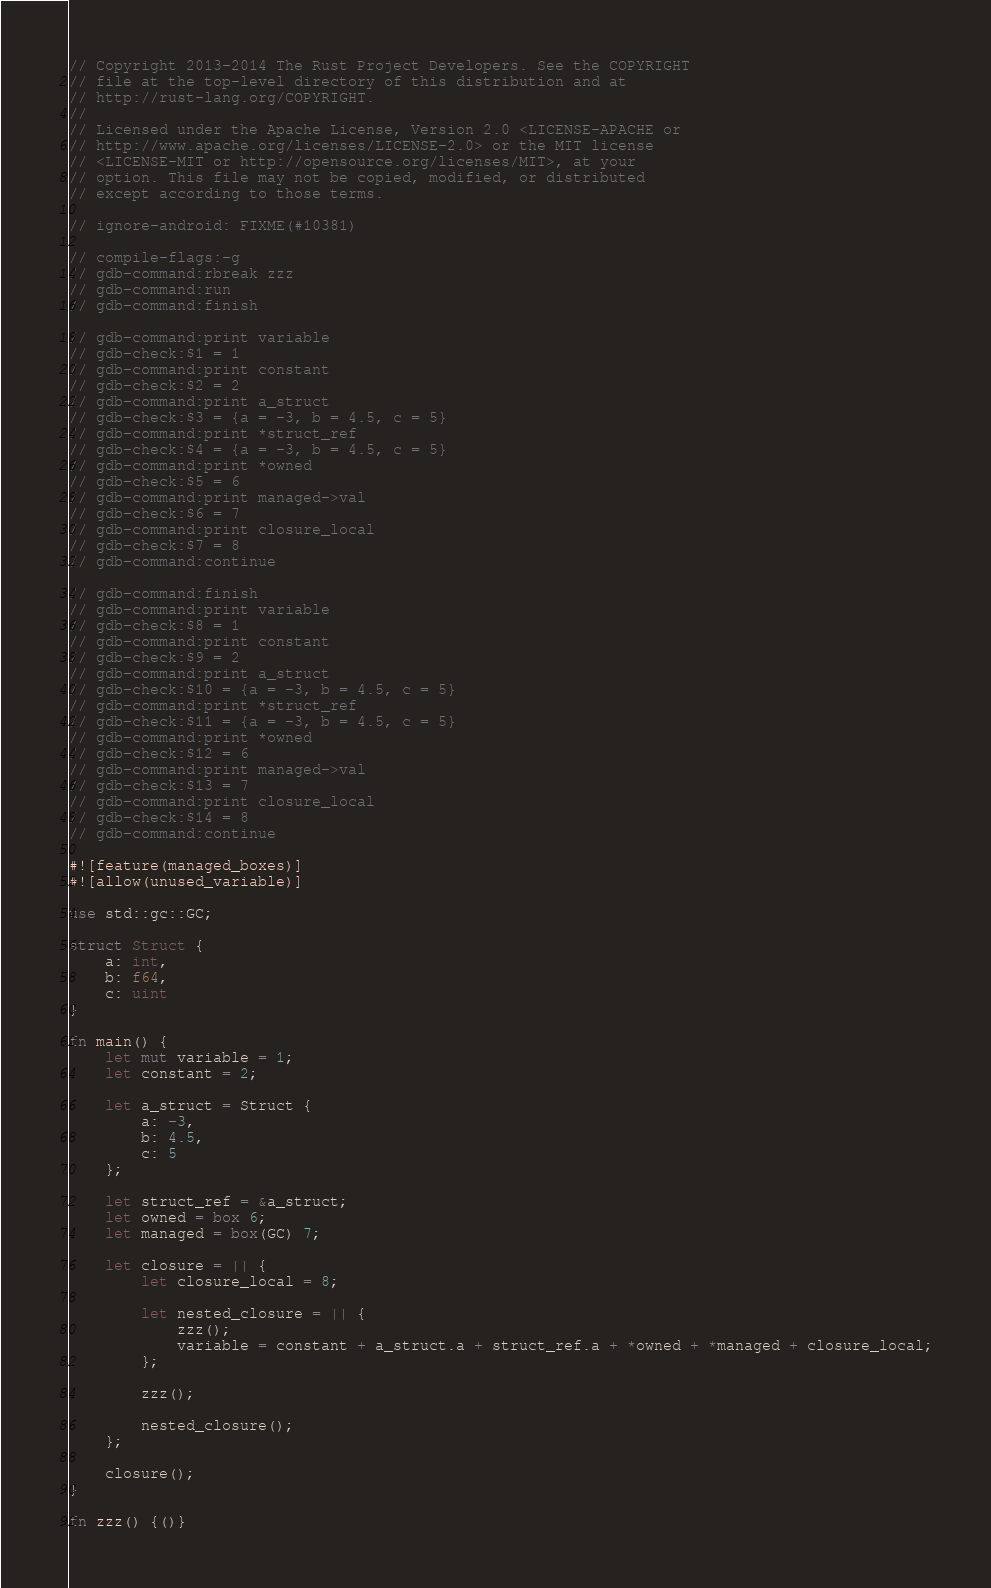Convert code to text. <code><loc_0><loc_0><loc_500><loc_500><_Rust_>// Copyright 2013-2014 The Rust Project Developers. See the COPYRIGHT
// file at the top-level directory of this distribution and at
// http://rust-lang.org/COPYRIGHT.
//
// Licensed under the Apache License, Version 2.0 <LICENSE-APACHE or
// http://www.apache.org/licenses/LICENSE-2.0> or the MIT license
// <LICENSE-MIT or http://opensource.org/licenses/MIT>, at your
// option. This file may not be copied, modified, or distributed
// except according to those terms.

// ignore-android: FIXME(#10381)

// compile-flags:-g
// gdb-command:rbreak zzz
// gdb-command:run
// gdb-command:finish

// gdb-command:print variable
// gdb-check:$1 = 1
// gdb-command:print constant
// gdb-check:$2 = 2
// gdb-command:print a_struct
// gdb-check:$3 = {a = -3, b = 4.5, c = 5}
// gdb-command:print *struct_ref
// gdb-check:$4 = {a = -3, b = 4.5, c = 5}
// gdb-command:print *owned
// gdb-check:$5 = 6
// gdb-command:print managed->val
// gdb-check:$6 = 7
// gdb-command:print closure_local
// gdb-check:$7 = 8
// gdb-command:continue

// gdb-command:finish
// gdb-command:print variable
// gdb-check:$8 = 1
// gdb-command:print constant
// gdb-check:$9 = 2
// gdb-command:print a_struct
// gdb-check:$10 = {a = -3, b = 4.5, c = 5}
// gdb-command:print *struct_ref
// gdb-check:$11 = {a = -3, b = 4.5, c = 5}
// gdb-command:print *owned
// gdb-check:$12 = 6
// gdb-command:print managed->val
// gdb-check:$13 = 7
// gdb-command:print closure_local
// gdb-check:$14 = 8
// gdb-command:continue

#![feature(managed_boxes)]
#![allow(unused_variable)]

use std::gc::GC;

struct Struct {
    a: int,
    b: f64,
    c: uint
}

fn main() {
    let mut variable = 1;
    let constant = 2;

    let a_struct = Struct {
        a: -3,
        b: 4.5,
        c: 5
    };

    let struct_ref = &a_struct;
    let owned = box 6;
    let managed = box(GC) 7;

    let closure = || {
        let closure_local = 8;

        let nested_closure = || {
            zzz();
            variable = constant + a_struct.a + struct_ref.a + *owned + *managed + closure_local;
        };

        zzz();

        nested_closure();
    };

    closure();
}

fn zzz() {()}
</code> 